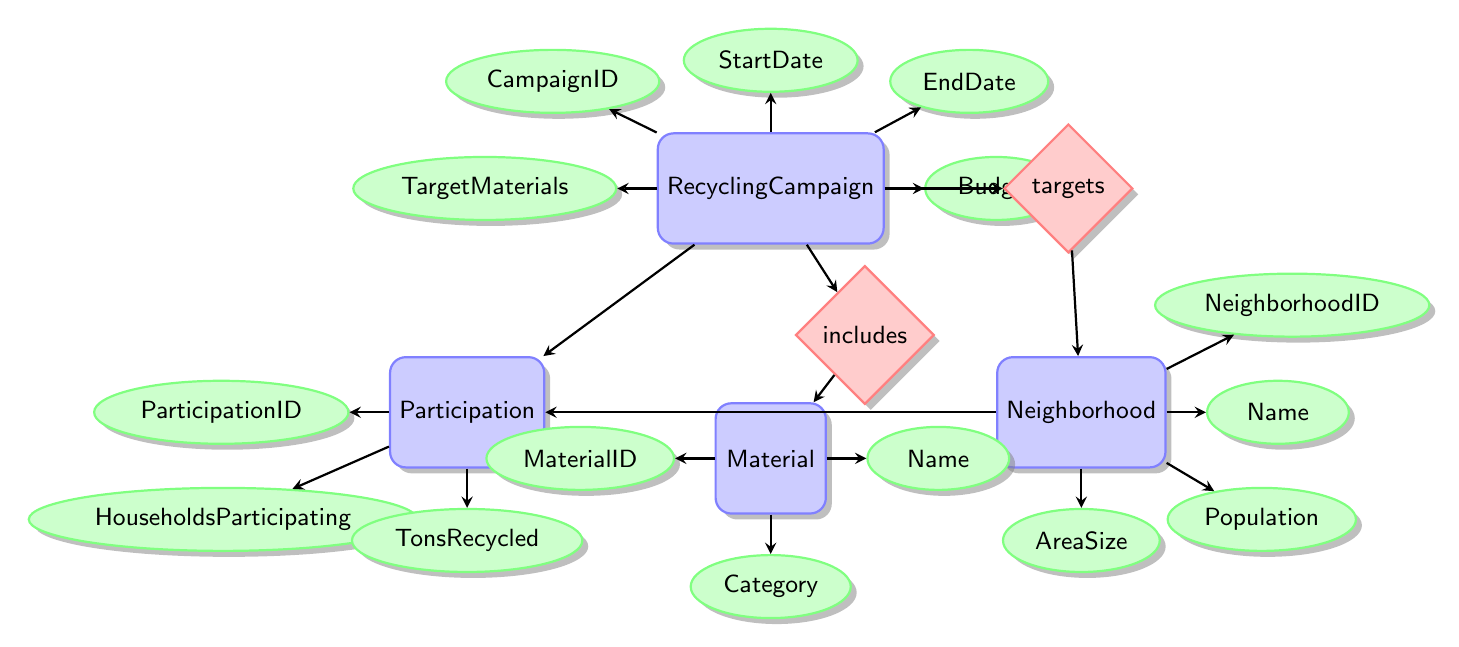What are the attributes of the RecyclingCampaign entity? The RecyclingCampaign entity includes the attributes CampaignID, StartDate, EndDate, TargetMaterials, and Budget as indicated by the lines connecting to the entity.
Answer: CampaignID, StartDate, EndDate, TargetMaterials, Budget How many attributes are associated with the Neighborhood entity? The Neighborhood entity has four attributes: NeighborhoodID, Name, Population, and AreaSize. This is determined by counting the connections to the Neighborhood entity.
Answer: 4 What relationship connects RecyclingCampaign and Material? The diagram shows that the RecyclingCampaign and Material entities are connected by the "includes" relationship, as indicated by the diamond shape positioned between the two entities.
Answer: includes What is the number of entities in this diagram? By counting the number of distinct entities listed in the diagram, we find that there are four entities: RecyclingCampaign, Neighborhood, Participation, and Material.
Answer: 4 How many participation records are linked to a RecyclingCampaign? The participation records are connected to the RecyclingCampaign through the Participation entity. Each Participation record corresponds to one RecyclingCampaign, as seen by the line connecting them. The exact number isn't specified within the diagram, but the relationship exists.
Answer: unspecified Which entity is associated with the attribute 'TonsRecycled'? The attribute 'TonsRecycled' is associated with the Participation entity, as it emerges from the lines connected to the Participation entity specifically.
Answer: Participation What does the 'targets' relationship indicate? The 'targets' relationship indicates that a RecyclingCampaign is directed at or aims to influence a specific Neighborhood, as depicted by the line connecting the RecyclingCampaign entity to the Neighborhood entity through the targets relationship.
Answer: targets Which neighborhood attributes might influence participation in recycling? The attributes that could influence participation in recycling are Population and AreaSize, as these directly relate to the number of households available and the community's space for carrying out recycling efforts.
Answer: Population, AreaSize 